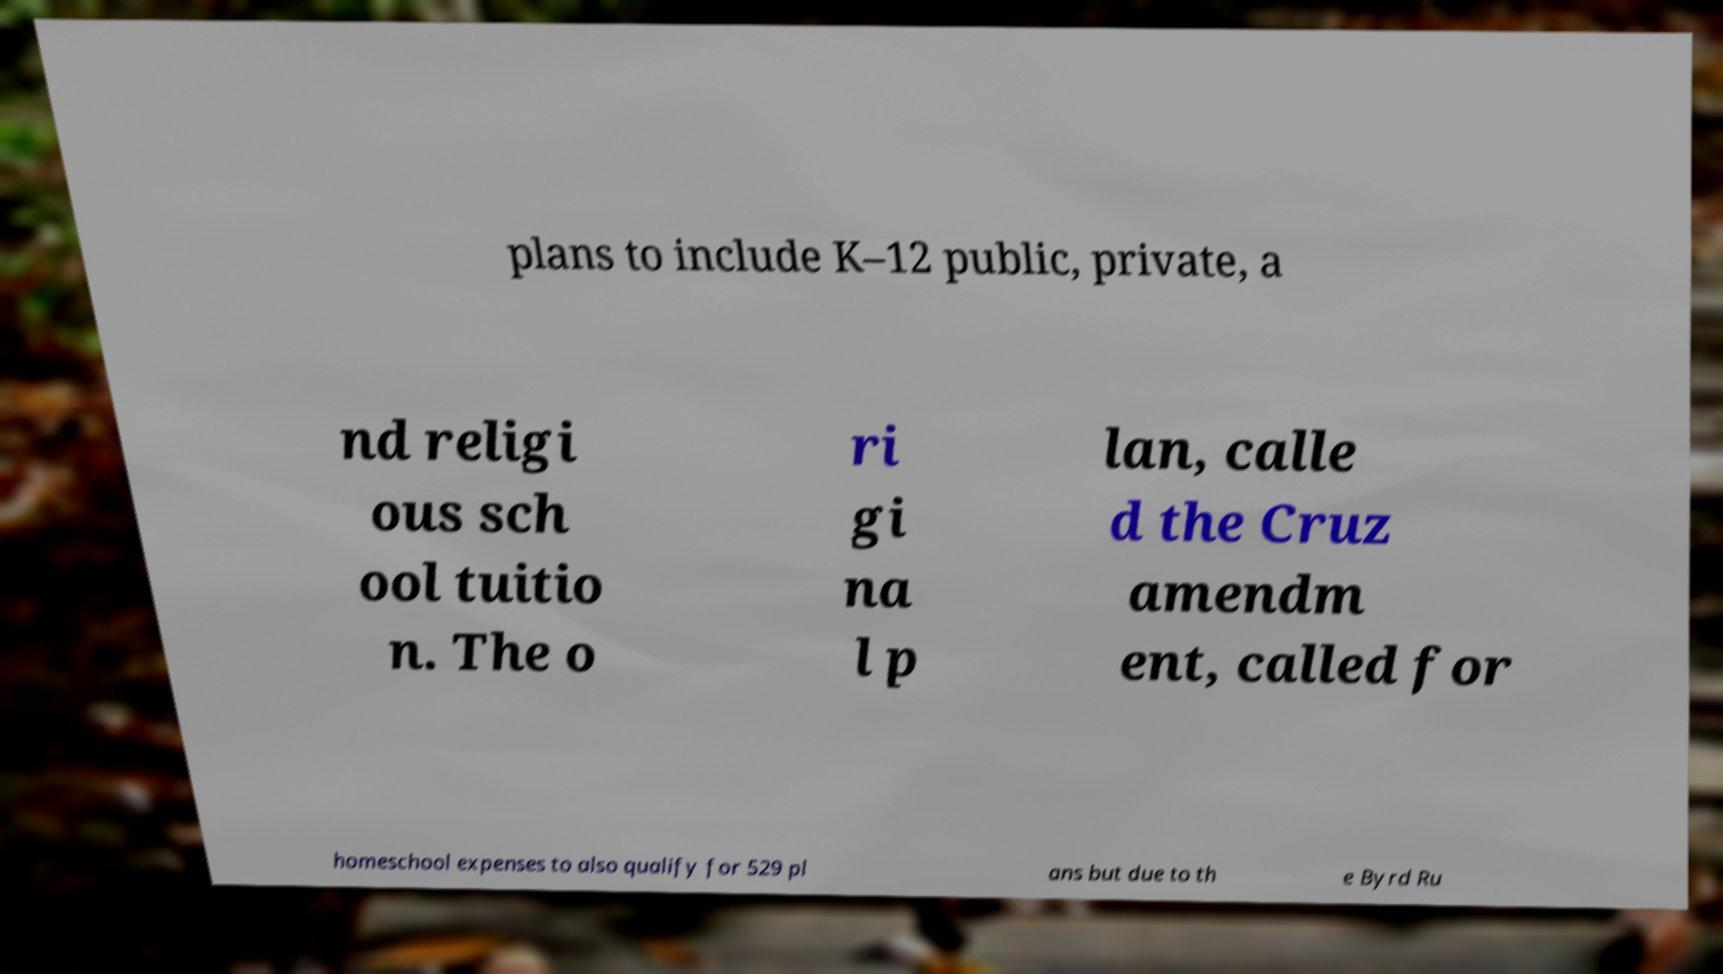What messages or text are displayed in this image? I need them in a readable, typed format. plans to include K–12 public, private, a nd religi ous sch ool tuitio n. The o ri gi na l p lan, calle d the Cruz amendm ent, called for homeschool expenses to also qualify for 529 pl ans but due to th e Byrd Ru 